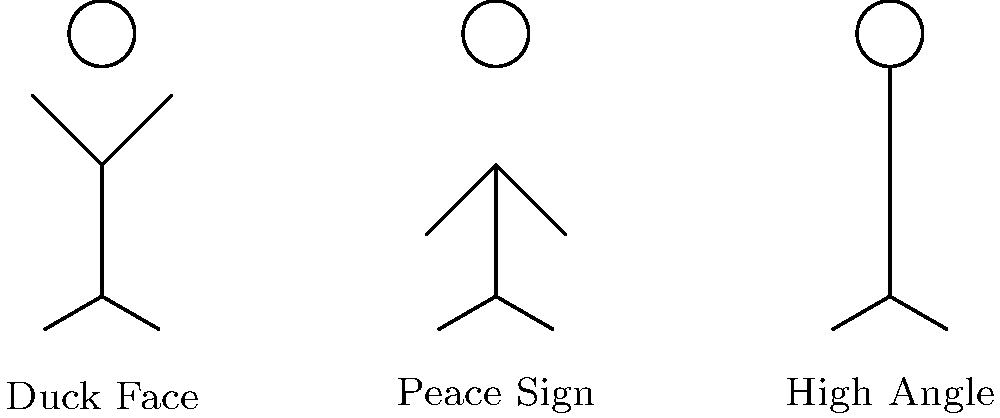Hey there, selfie squad! 📸✨ Time to flex those #SelfieSkills! Which of these stick figure poses is giving us major "I'm totally not trying too hard" vibes with that classic high angle shot? Drop your answer in the comments and let's see who's the real #SelfieExpert! 🤳🔍 Alright, let's break this down for all you aspiring #SelfieQueen and #SelfieKing contenders! 👑

1. First stick figure (left):
   - Arms angled slightly upwards
   - Label says "Duck Face"
   - This is not our high angle pose

2. Second stick figure (center):
   - Arms angled slightly downwards
   - Label says "Peace Sign"
   - Also not our high angle pose

3. Third stick figure (right):
   - Arms raised high above the head
   - Label says "High Angle"
   - Bingo! This is our winner! 🎉

The high angle selfie is all about holding your phone above eye level and angling it downwards. This stick figure perfectly captures that pose with its arms raised high, mimicking how you'd hold your phone for that flattering high angle shot.

Remember, the high angle selfie is a classic for a reason:
- It elongates your neck
- Defines your jawline
- Makes your eyes look bigger

So, next time you're aiming for that perfect selfie, channel your inner stick figure and raise those arms high! It's all about that #AngleGame, fam! 📐✨
Answer: Third stick figure (right) 